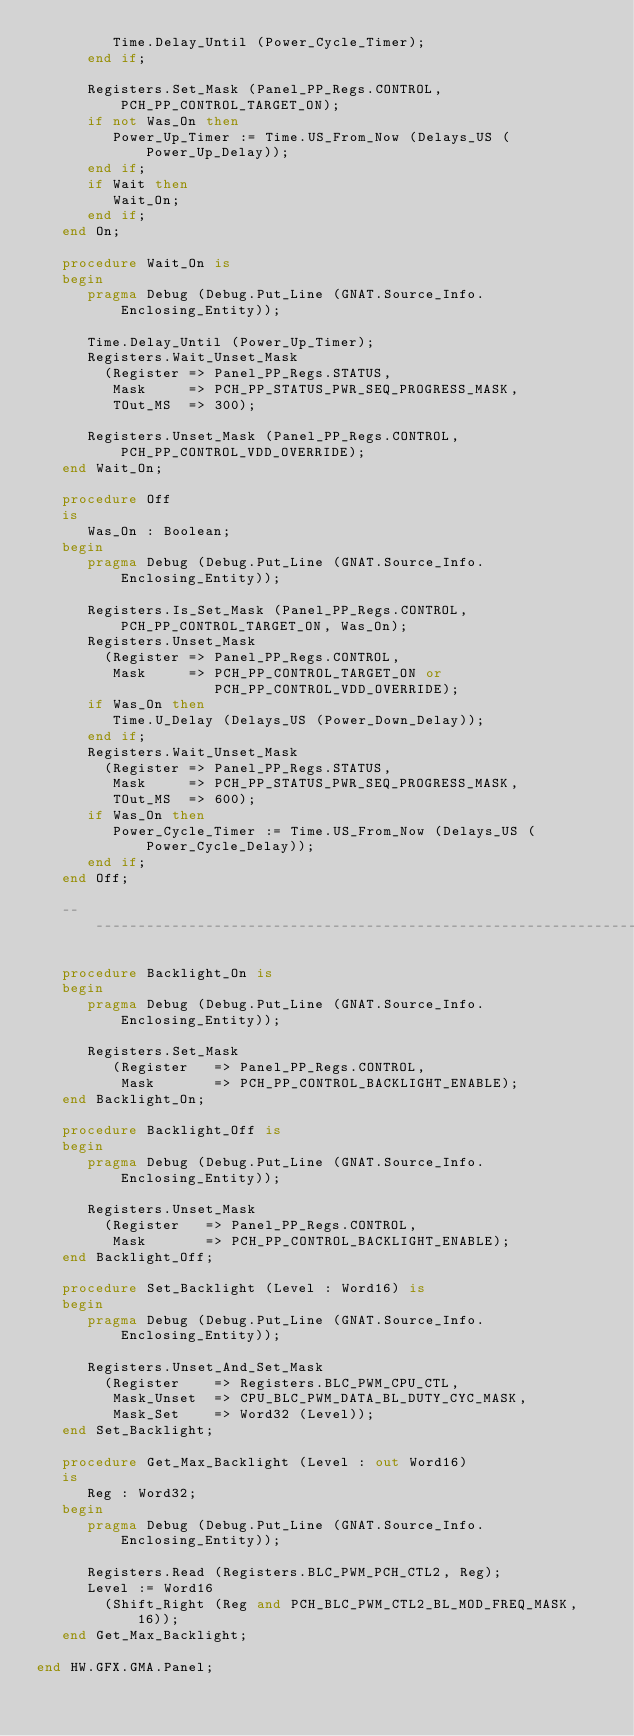<code> <loc_0><loc_0><loc_500><loc_500><_Ada_>         Time.Delay_Until (Power_Cycle_Timer);
      end if;

      Registers.Set_Mask (Panel_PP_Regs.CONTROL, PCH_PP_CONTROL_TARGET_ON);
      if not Was_On then
         Power_Up_Timer := Time.US_From_Now (Delays_US (Power_Up_Delay));
      end if;
      if Wait then
         Wait_On;
      end if;
   end On;

   procedure Wait_On is
   begin
      pragma Debug (Debug.Put_Line (GNAT.Source_Info.Enclosing_Entity));

      Time.Delay_Until (Power_Up_Timer);
      Registers.Wait_Unset_Mask
        (Register => Panel_PP_Regs.STATUS,
         Mask     => PCH_PP_STATUS_PWR_SEQ_PROGRESS_MASK,
         TOut_MS  => 300);

      Registers.Unset_Mask (Panel_PP_Regs.CONTROL, PCH_PP_CONTROL_VDD_OVERRIDE);
   end Wait_On;

   procedure Off
   is
      Was_On : Boolean;
   begin
      pragma Debug (Debug.Put_Line (GNAT.Source_Info.Enclosing_Entity));

      Registers.Is_Set_Mask (Panel_PP_Regs.CONTROL, PCH_PP_CONTROL_TARGET_ON, Was_On);
      Registers.Unset_Mask
        (Register => Panel_PP_Regs.CONTROL,
         Mask     => PCH_PP_CONTROL_TARGET_ON or
                     PCH_PP_CONTROL_VDD_OVERRIDE);
      if Was_On then
         Time.U_Delay (Delays_US (Power_Down_Delay));
      end if;
      Registers.Wait_Unset_Mask
        (Register => Panel_PP_Regs.STATUS,
         Mask     => PCH_PP_STATUS_PWR_SEQ_PROGRESS_MASK,
         TOut_MS  => 600);
      if Was_On then
         Power_Cycle_Timer := Time.US_From_Now (Delays_US (Power_Cycle_Delay));
      end if;
   end Off;

   ----------------------------------------------------------------------------

   procedure Backlight_On is
   begin
      pragma Debug (Debug.Put_Line (GNAT.Source_Info.Enclosing_Entity));

      Registers.Set_Mask
         (Register   => Panel_PP_Regs.CONTROL,
          Mask       => PCH_PP_CONTROL_BACKLIGHT_ENABLE);
   end Backlight_On;

   procedure Backlight_Off is
   begin
      pragma Debug (Debug.Put_Line (GNAT.Source_Info.Enclosing_Entity));

      Registers.Unset_Mask
        (Register   => Panel_PP_Regs.CONTROL,
         Mask       => PCH_PP_CONTROL_BACKLIGHT_ENABLE);
   end Backlight_Off;

   procedure Set_Backlight (Level : Word16) is
   begin
      pragma Debug (Debug.Put_Line (GNAT.Source_Info.Enclosing_Entity));

      Registers.Unset_And_Set_Mask
        (Register    => Registers.BLC_PWM_CPU_CTL,
         Mask_Unset  => CPU_BLC_PWM_DATA_BL_DUTY_CYC_MASK,
         Mask_Set    => Word32 (Level));
   end Set_Backlight;

   procedure Get_Max_Backlight (Level : out Word16)
   is
      Reg : Word32;
   begin
      pragma Debug (Debug.Put_Line (GNAT.Source_Info.Enclosing_Entity));

      Registers.Read (Registers.BLC_PWM_PCH_CTL2, Reg);
      Level := Word16
        (Shift_Right (Reg and PCH_BLC_PWM_CTL2_BL_MOD_FREQ_MASK, 16));
   end Get_Max_Backlight;

end HW.GFX.GMA.Panel;
</code> 